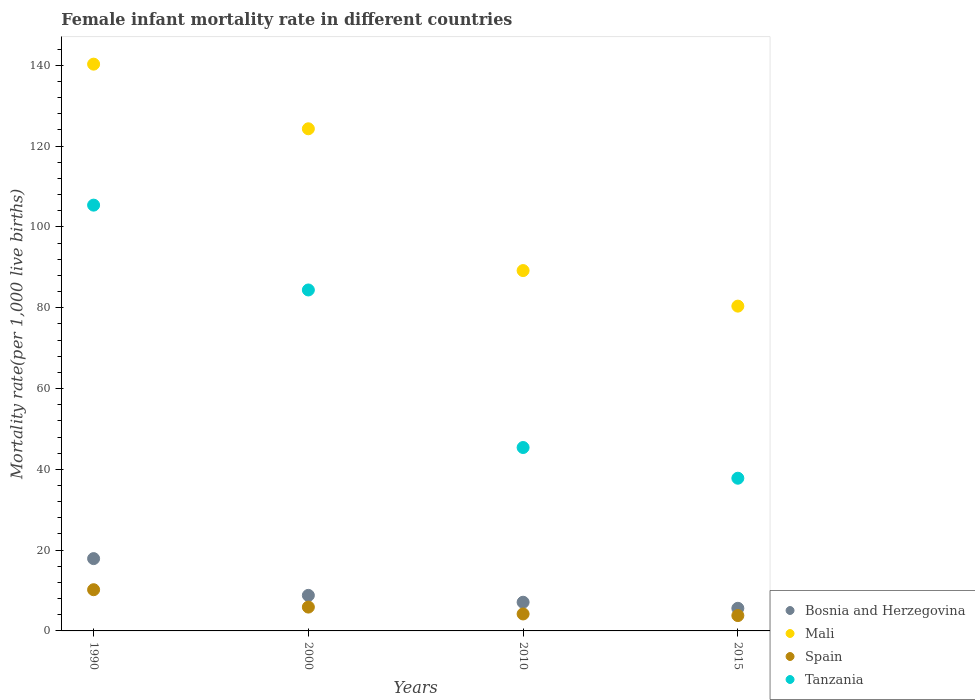What is the female infant mortality rate in Tanzania in 2010?
Ensure brevity in your answer.  45.4. Across all years, what is the maximum female infant mortality rate in Tanzania?
Offer a terse response. 105.4. Across all years, what is the minimum female infant mortality rate in Mali?
Provide a short and direct response. 80.4. In which year was the female infant mortality rate in Mali maximum?
Offer a very short reply. 1990. In which year was the female infant mortality rate in Mali minimum?
Give a very brief answer. 2015. What is the total female infant mortality rate in Spain in the graph?
Provide a short and direct response. 24.1. What is the difference between the female infant mortality rate in Mali in 1990 and that in 2010?
Offer a terse response. 51.1. What is the difference between the female infant mortality rate in Spain in 1990 and the female infant mortality rate in Bosnia and Herzegovina in 2010?
Your answer should be very brief. 3.1. What is the average female infant mortality rate in Spain per year?
Ensure brevity in your answer.  6.03. In the year 2015, what is the difference between the female infant mortality rate in Tanzania and female infant mortality rate in Mali?
Your response must be concise. -42.6. What is the ratio of the female infant mortality rate in Spain in 2000 to that in 2010?
Keep it short and to the point. 1.4. Is the female infant mortality rate in Bosnia and Herzegovina in 1990 less than that in 2000?
Your response must be concise. No. Is the difference between the female infant mortality rate in Tanzania in 2000 and 2010 greater than the difference between the female infant mortality rate in Mali in 2000 and 2010?
Offer a very short reply. Yes. What is the difference between the highest and the second highest female infant mortality rate in Bosnia and Herzegovina?
Your answer should be compact. 9.1. What is the difference between the highest and the lowest female infant mortality rate in Tanzania?
Ensure brevity in your answer.  67.6. In how many years, is the female infant mortality rate in Tanzania greater than the average female infant mortality rate in Tanzania taken over all years?
Provide a succinct answer. 2. Is it the case that in every year, the sum of the female infant mortality rate in Bosnia and Herzegovina and female infant mortality rate in Spain  is greater than the sum of female infant mortality rate in Mali and female infant mortality rate in Tanzania?
Provide a short and direct response. No. Is the female infant mortality rate in Tanzania strictly greater than the female infant mortality rate in Mali over the years?
Ensure brevity in your answer.  No. How many dotlines are there?
Make the answer very short. 4. What is the difference between two consecutive major ticks on the Y-axis?
Ensure brevity in your answer.  20. Does the graph contain any zero values?
Provide a short and direct response. No. Where does the legend appear in the graph?
Make the answer very short. Bottom right. How many legend labels are there?
Offer a very short reply. 4. What is the title of the graph?
Provide a succinct answer. Female infant mortality rate in different countries. Does "Ukraine" appear as one of the legend labels in the graph?
Make the answer very short. No. What is the label or title of the Y-axis?
Keep it short and to the point. Mortality rate(per 1,0 live births). What is the Mortality rate(per 1,000 live births) in Bosnia and Herzegovina in 1990?
Offer a very short reply. 17.9. What is the Mortality rate(per 1,000 live births) in Mali in 1990?
Give a very brief answer. 140.3. What is the Mortality rate(per 1,000 live births) of Spain in 1990?
Your answer should be compact. 10.2. What is the Mortality rate(per 1,000 live births) of Tanzania in 1990?
Your answer should be compact. 105.4. What is the Mortality rate(per 1,000 live births) in Bosnia and Herzegovina in 2000?
Provide a short and direct response. 8.8. What is the Mortality rate(per 1,000 live births) in Mali in 2000?
Your response must be concise. 124.3. What is the Mortality rate(per 1,000 live births) of Spain in 2000?
Give a very brief answer. 5.9. What is the Mortality rate(per 1,000 live births) in Tanzania in 2000?
Keep it short and to the point. 84.4. What is the Mortality rate(per 1,000 live births) of Mali in 2010?
Provide a succinct answer. 89.2. What is the Mortality rate(per 1,000 live births) in Spain in 2010?
Give a very brief answer. 4.2. What is the Mortality rate(per 1,000 live births) of Tanzania in 2010?
Offer a terse response. 45.4. What is the Mortality rate(per 1,000 live births) in Mali in 2015?
Your response must be concise. 80.4. What is the Mortality rate(per 1,000 live births) in Spain in 2015?
Offer a very short reply. 3.8. What is the Mortality rate(per 1,000 live births) in Tanzania in 2015?
Give a very brief answer. 37.8. Across all years, what is the maximum Mortality rate(per 1,000 live births) in Bosnia and Herzegovina?
Give a very brief answer. 17.9. Across all years, what is the maximum Mortality rate(per 1,000 live births) of Mali?
Make the answer very short. 140.3. Across all years, what is the maximum Mortality rate(per 1,000 live births) in Tanzania?
Your answer should be very brief. 105.4. Across all years, what is the minimum Mortality rate(per 1,000 live births) in Bosnia and Herzegovina?
Provide a short and direct response. 5.6. Across all years, what is the minimum Mortality rate(per 1,000 live births) of Mali?
Offer a terse response. 80.4. Across all years, what is the minimum Mortality rate(per 1,000 live births) of Spain?
Offer a very short reply. 3.8. Across all years, what is the minimum Mortality rate(per 1,000 live births) in Tanzania?
Your response must be concise. 37.8. What is the total Mortality rate(per 1,000 live births) of Bosnia and Herzegovina in the graph?
Your answer should be very brief. 39.4. What is the total Mortality rate(per 1,000 live births) in Mali in the graph?
Make the answer very short. 434.2. What is the total Mortality rate(per 1,000 live births) in Spain in the graph?
Provide a short and direct response. 24.1. What is the total Mortality rate(per 1,000 live births) of Tanzania in the graph?
Give a very brief answer. 273. What is the difference between the Mortality rate(per 1,000 live births) in Bosnia and Herzegovina in 1990 and that in 2010?
Offer a very short reply. 10.8. What is the difference between the Mortality rate(per 1,000 live births) in Mali in 1990 and that in 2010?
Your answer should be compact. 51.1. What is the difference between the Mortality rate(per 1,000 live births) of Spain in 1990 and that in 2010?
Ensure brevity in your answer.  6. What is the difference between the Mortality rate(per 1,000 live births) in Bosnia and Herzegovina in 1990 and that in 2015?
Your response must be concise. 12.3. What is the difference between the Mortality rate(per 1,000 live births) of Mali in 1990 and that in 2015?
Offer a terse response. 59.9. What is the difference between the Mortality rate(per 1,000 live births) in Tanzania in 1990 and that in 2015?
Provide a succinct answer. 67.6. What is the difference between the Mortality rate(per 1,000 live births) in Mali in 2000 and that in 2010?
Your answer should be compact. 35.1. What is the difference between the Mortality rate(per 1,000 live births) in Spain in 2000 and that in 2010?
Provide a succinct answer. 1.7. What is the difference between the Mortality rate(per 1,000 live births) of Bosnia and Herzegovina in 2000 and that in 2015?
Provide a short and direct response. 3.2. What is the difference between the Mortality rate(per 1,000 live births) of Mali in 2000 and that in 2015?
Offer a terse response. 43.9. What is the difference between the Mortality rate(per 1,000 live births) of Spain in 2000 and that in 2015?
Provide a succinct answer. 2.1. What is the difference between the Mortality rate(per 1,000 live births) in Tanzania in 2000 and that in 2015?
Ensure brevity in your answer.  46.6. What is the difference between the Mortality rate(per 1,000 live births) of Bosnia and Herzegovina in 2010 and that in 2015?
Provide a succinct answer. 1.5. What is the difference between the Mortality rate(per 1,000 live births) in Spain in 2010 and that in 2015?
Ensure brevity in your answer.  0.4. What is the difference between the Mortality rate(per 1,000 live births) in Tanzania in 2010 and that in 2015?
Your answer should be compact. 7.6. What is the difference between the Mortality rate(per 1,000 live births) in Bosnia and Herzegovina in 1990 and the Mortality rate(per 1,000 live births) in Mali in 2000?
Give a very brief answer. -106.4. What is the difference between the Mortality rate(per 1,000 live births) of Bosnia and Herzegovina in 1990 and the Mortality rate(per 1,000 live births) of Tanzania in 2000?
Keep it short and to the point. -66.5. What is the difference between the Mortality rate(per 1,000 live births) of Mali in 1990 and the Mortality rate(per 1,000 live births) of Spain in 2000?
Your answer should be very brief. 134.4. What is the difference between the Mortality rate(per 1,000 live births) in Mali in 1990 and the Mortality rate(per 1,000 live births) in Tanzania in 2000?
Make the answer very short. 55.9. What is the difference between the Mortality rate(per 1,000 live births) of Spain in 1990 and the Mortality rate(per 1,000 live births) of Tanzania in 2000?
Give a very brief answer. -74.2. What is the difference between the Mortality rate(per 1,000 live births) of Bosnia and Herzegovina in 1990 and the Mortality rate(per 1,000 live births) of Mali in 2010?
Offer a very short reply. -71.3. What is the difference between the Mortality rate(per 1,000 live births) of Bosnia and Herzegovina in 1990 and the Mortality rate(per 1,000 live births) of Tanzania in 2010?
Provide a short and direct response. -27.5. What is the difference between the Mortality rate(per 1,000 live births) in Mali in 1990 and the Mortality rate(per 1,000 live births) in Spain in 2010?
Ensure brevity in your answer.  136.1. What is the difference between the Mortality rate(per 1,000 live births) in Mali in 1990 and the Mortality rate(per 1,000 live births) in Tanzania in 2010?
Give a very brief answer. 94.9. What is the difference between the Mortality rate(per 1,000 live births) in Spain in 1990 and the Mortality rate(per 1,000 live births) in Tanzania in 2010?
Make the answer very short. -35.2. What is the difference between the Mortality rate(per 1,000 live births) of Bosnia and Herzegovina in 1990 and the Mortality rate(per 1,000 live births) of Mali in 2015?
Keep it short and to the point. -62.5. What is the difference between the Mortality rate(per 1,000 live births) in Bosnia and Herzegovina in 1990 and the Mortality rate(per 1,000 live births) in Tanzania in 2015?
Ensure brevity in your answer.  -19.9. What is the difference between the Mortality rate(per 1,000 live births) in Mali in 1990 and the Mortality rate(per 1,000 live births) in Spain in 2015?
Provide a succinct answer. 136.5. What is the difference between the Mortality rate(per 1,000 live births) of Mali in 1990 and the Mortality rate(per 1,000 live births) of Tanzania in 2015?
Provide a short and direct response. 102.5. What is the difference between the Mortality rate(per 1,000 live births) in Spain in 1990 and the Mortality rate(per 1,000 live births) in Tanzania in 2015?
Your answer should be compact. -27.6. What is the difference between the Mortality rate(per 1,000 live births) in Bosnia and Herzegovina in 2000 and the Mortality rate(per 1,000 live births) in Mali in 2010?
Your response must be concise. -80.4. What is the difference between the Mortality rate(per 1,000 live births) of Bosnia and Herzegovina in 2000 and the Mortality rate(per 1,000 live births) of Spain in 2010?
Make the answer very short. 4.6. What is the difference between the Mortality rate(per 1,000 live births) in Bosnia and Herzegovina in 2000 and the Mortality rate(per 1,000 live births) in Tanzania in 2010?
Ensure brevity in your answer.  -36.6. What is the difference between the Mortality rate(per 1,000 live births) in Mali in 2000 and the Mortality rate(per 1,000 live births) in Spain in 2010?
Your answer should be very brief. 120.1. What is the difference between the Mortality rate(per 1,000 live births) in Mali in 2000 and the Mortality rate(per 1,000 live births) in Tanzania in 2010?
Ensure brevity in your answer.  78.9. What is the difference between the Mortality rate(per 1,000 live births) of Spain in 2000 and the Mortality rate(per 1,000 live births) of Tanzania in 2010?
Keep it short and to the point. -39.5. What is the difference between the Mortality rate(per 1,000 live births) in Bosnia and Herzegovina in 2000 and the Mortality rate(per 1,000 live births) in Mali in 2015?
Provide a succinct answer. -71.6. What is the difference between the Mortality rate(per 1,000 live births) in Bosnia and Herzegovina in 2000 and the Mortality rate(per 1,000 live births) in Tanzania in 2015?
Provide a succinct answer. -29. What is the difference between the Mortality rate(per 1,000 live births) of Mali in 2000 and the Mortality rate(per 1,000 live births) of Spain in 2015?
Provide a short and direct response. 120.5. What is the difference between the Mortality rate(per 1,000 live births) of Mali in 2000 and the Mortality rate(per 1,000 live births) of Tanzania in 2015?
Your answer should be very brief. 86.5. What is the difference between the Mortality rate(per 1,000 live births) in Spain in 2000 and the Mortality rate(per 1,000 live births) in Tanzania in 2015?
Provide a succinct answer. -31.9. What is the difference between the Mortality rate(per 1,000 live births) of Bosnia and Herzegovina in 2010 and the Mortality rate(per 1,000 live births) of Mali in 2015?
Provide a short and direct response. -73.3. What is the difference between the Mortality rate(per 1,000 live births) of Bosnia and Herzegovina in 2010 and the Mortality rate(per 1,000 live births) of Tanzania in 2015?
Provide a short and direct response. -30.7. What is the difference between the Mortality rate(per 1,000 live births) of Mali in 2010 and the Mortality rate(per 1,000 live births) of Spain in 2015?
Your answer should be very brief. 85.4. What is the difference between the Mortality rate(per 1,000 live births) in Mali in 2010 and the Mortality rate(per 1,000 live births) in Tanzania in 2015?
Your answer should be compact. 51.4. What is the difference between the Mortality rate(per 1,000 live births) in Spain in 2010 and the Mortality rate(per 1,000 live births) in Tanzania in 2015?
Ensure brevity in your answer.  -33.6. What is the average Mortality rate(per 1,000 live births) in Bosnia and Herzegovina per year?
Provide a succinct answer. 9.85. What is the average Mortality rate(per 1,000 live births) of Mali per year?
Give a very brief answer. 108.55. What is the average Mortality rate(per 1,000 live births) of Spain per year?
Your answer should be very brief. 6.03. What is the average Mortality rate(per 1,000 live births) in Tanzania per year?
Provide a succinct answer. 68.25. In the year 1990, what is the difference between the Mortality rate(per 1,000 live births) in Bosnia and Herzegovina and Mortality rate(per 1,000 live births) in Mali?
Give a very brief answer. -122.4. In the year 1990, what is the difference between the Mortality rate(per 1,000 live births) of Bosnia and Herzegovina and Mortality rate(per 1,000 live births) of Tanzania?
Offer a very short reply. -87.5. In the year 1990, what is the difference between the Mortality rate(per 1,000 live births) of Mali and Mortality rate(per 1,000 live births) of Spain?
Your answer should be very brief. 130.1. In the year 1990, what is the difference between the Mortality rate(per 1,000 live births) of Mali and Mortality rate(per 1,000 live births) of Tanzania?
Ensure brevity in your answer.  34.9. In the year 1990, what is the difference between the Mortality rate(per 1,000 live births) of Spain and Mortality rate(per 1,000 live births) of Tanzania?
Your answer should be compact. -95.2. In the year 2000, what is the difference between the Mortality rate(per 1,000 live births) of Bosnia and Herzegovina and Mortality rate(per 1,000 live births) of Mali?
Your answer should be very brief. -115.5. In the year 2000, what is the difference between the Mortality rate(per 1,000 live births) of Bosnia and Herzegovina and Mortality rate(per 1,000 live births) of Spain?
Provide a short and direct response. 2.9. In the year 2000, what is the difference between the Mortality rate(per 1,000 live births) of Bosnia and Herzegovina and Mortality rate(per 1,000 live births) of Tanzania?
Give a very brief answer. -75.6. In the year 2000, what is the difference between the Mortality rate(per 1,000 live births) in Mali and Mortality rate(per 1,000 live births) in Spain?
Provide a succinct answer. 118.4. In the year 2000, what is the difference between the Mortality rate(per 1,000 live births) of Mali and Mortality rate(per 1,000 live births) of Tanzania?
Give a very brief answer. 39.9. In the year 2000, what is the difference between the Mortality rate(per 1,000 live births) of Spain and Mortality rate(per 1,000 live births) of Tanzania?
Make the answer very short. -78.5. In the year 2010, what is the difference between the Mortality rate(per 1,000 live births) in Bosnia and Herzegovina and Mortality rate(per 1,000 live births) in Mali?
Keep it short and to the point. -82.1. In the year 2010, what is the difference between the Mortality rate(per 1,000 live births) in Bosnia and Herzegovina and Mortality rate(per 1,000 live births) in Tanzania?
Offer a very short reply. -38.3. In the year 2010, what is the difference between the Mortality rate(per 1,000 live births) of Mali and Mortality rate(per 1,000 live births) of Tanzania?
Your answer should be compact. 43.8. In the year 2010, what is the difference between the Mortality rate(per 1,000 live births) in Spain and Mortality rate(per 1,000 live births) in Tanzania?
Provide a succinct answer. -41.2. In the year 2015, what is the difference between the Mortality rate(per 1,000 live births) in Bosnia and Herzegovina and Mortality rate(per 1,000 live births) in Mali?
Make the answer very short. -74.8. In the year 2015, what is the difference between the Mortality rate(per 1,000 live births) in Bosnia and Herzegovina and Mortality rate(per 1,000 live births) in Spain?
Make the answer very short. 1.8. In the year 2015, what is the difference between the Mortality rate(per 1,000 live births) of Bosnia and Herzegovina and Mortality rate(per 1,000 live births) of Tanzania?
Provide a succinct answer. -32.2. In the year 2015, what is the difference between the Mortality rate(per 1,000 live births) of Mali and Mortality rate(per 1,000 live births) of Spain?
Ensure brevity in your answer.  76.6. In the year 2015, what is the difference between the Mortality rate(per 1,000 live births) of Mali and Mortality rate(per 1,000 live births) of Tanzania?
Give a very brief answer. 42.6. In the year 2015, what is the difference between the Mortality rate(per 1,000 live births) in Spain and Mortality rate(per 1,000 live births) in Tanzania?
Provide a short and direct response. -34. What is the ratio of the Mortality rate(per 1,000 live births) in Bosnia and Herzegovina in 1990 to that in 2000?
Your answer should be very brief. 2.03. What is the ratio of the Mortality rate(per 1,000 live births) in Mali in 1990 to that in 2000?
Provide a succinct answer. 1.13. What is the ratio of the Mortality rate(per 1,000 live births) of Spain in 1990 to that in 2000?
Provide a short and direct response. 1.73. What is the ratio of the Mortality rate(per 1,000 live births) in Tanzania in 1990 to that in 2000?
Make the answer very short. 1.25. What is the ratio of the Mortality rate(per 1,000 live births) of Bosnia and Herzegovina in 1990 to that in 2010?
Make the answer very short. 2.52. What is the ratio of the Mortality rate(per 1,000 live births) in Mali in 1990 to that in 2010?
Your answer should be very brief. 1.57. What is the ratio of the Mortality rate(per 1,000 live births) of Spain in 1990 to that in 2010?
Offer a very short reply. 2.43. What is the ratio of the Mortality rate(per 1,000 live births) of Tanzania in 1990 to that in 2010?
Offer a very short reply. 2.32. What is the ratio of the Mortality rate(per 1,000 live births) of Bosnia and Herzegovina in 1990 to that in 2015?
Provide a short and direct response. 3.2. What is the ratio of the Mortality rate(per 1,000 live births) of Mali in 1990 to that in 2015?
Keep it short and to the point. 1.75. What is the ratio of the Mortality rate(per 1,000 live births) of Spain in 1990 to that in 2015?
Provide a succinct answer. 2.68. What is the ratio of the Mortality rate(per 1,000 live births) in Tanzania in 1990 to that in 2015?
Keep it short and to the point. 2.79. What is the ratio of the Mortality rate(per 1,000 live births) of Bosnia and Herzegovina in 2000 to that in 2010?
Offer a very short reply. 1.24. What is the ratio of the Mortality rate(per 1,000 live births) in Mali in 2000 to that in 2010?
Ensure brevity in your answer.  1.39. What is the ratio of the Mortality rate(per 1,000 live births) in Spain in 2000 to that in 2010?
Your answer should be compact. 1.4. What is the ratio of the Mortality rate(per 1,000 live births) in Tanzania in 2000 to that in 2010?
Your answer should be compact. 1.86. What is the ratio of the Mortality rate(per 1,000 live births) of Bosnia and Herzegovina in 2000 to that in 2015?
Provide a short and direct response. 1.57. What is the ratio of the Mortality rate(per 1,000 live births) in Mali in 2000 to that in 2015?
Provide a succinct answer. 1.55. What is the ratio of the Mortality rate(per 1,000 live births) of Spain in 2000 to that in 2015?
Keep it short and to the point. 1.55. What is the ratio of the Mortality rate(per 1,000 live births) of Tanzania in 2000 to that in 2015?
Keep it short and to the point. 2.23. What is the ratio of the Mortality rate(per 1,000 live births) in Bosnia and Herzegovina in 2010 to that in 2015?
Make the answer very short. 1.27. What is the ratio of the Mortality rate(per 1,000 live births) in Mali in 2010 to that in 2015?
Make the answer very short. 1.11. What is the ratio of the Mortality rate(per 1,000 live births) of Spain in 2010 to that in 2015?
Provide a succinct answer. 1.11. What is the ratio of the Mortality rate(per 1,000 live births) in Tanzania in 2010 to that in 2015?
Provide a succinct answer. 1.2. What is the difference between the highest and the second highest Mortality rate(per 1,000 live births) in Bosnia and Herzegovina?
Ensure brevity in your answer.  9.1. What is the difference between the highest and the second highest Mortality rate(per 1,000 live births) of Spain?
Keep it short and to the point. 4.3. What is the difference between the highest and the second highest Mortality rate(per 1,000 live births) of Tanzania?
Your answer should be very brief. 21. What is the difference between the highest and the lowest Mortality rate(per 1,000 live births) in Bosnia and Herzegovina?
Your answer should be compact. 12.3. What is the difference between the highest and the lowest Mortality rate(per 1,000 live births) of Mali?
Provide a short and direct response. 59.9. What is the difference between the highest and the lowest Mortality rate(per 1,000 live births) of Tanzania?
Your response must be concise. 67.6. 